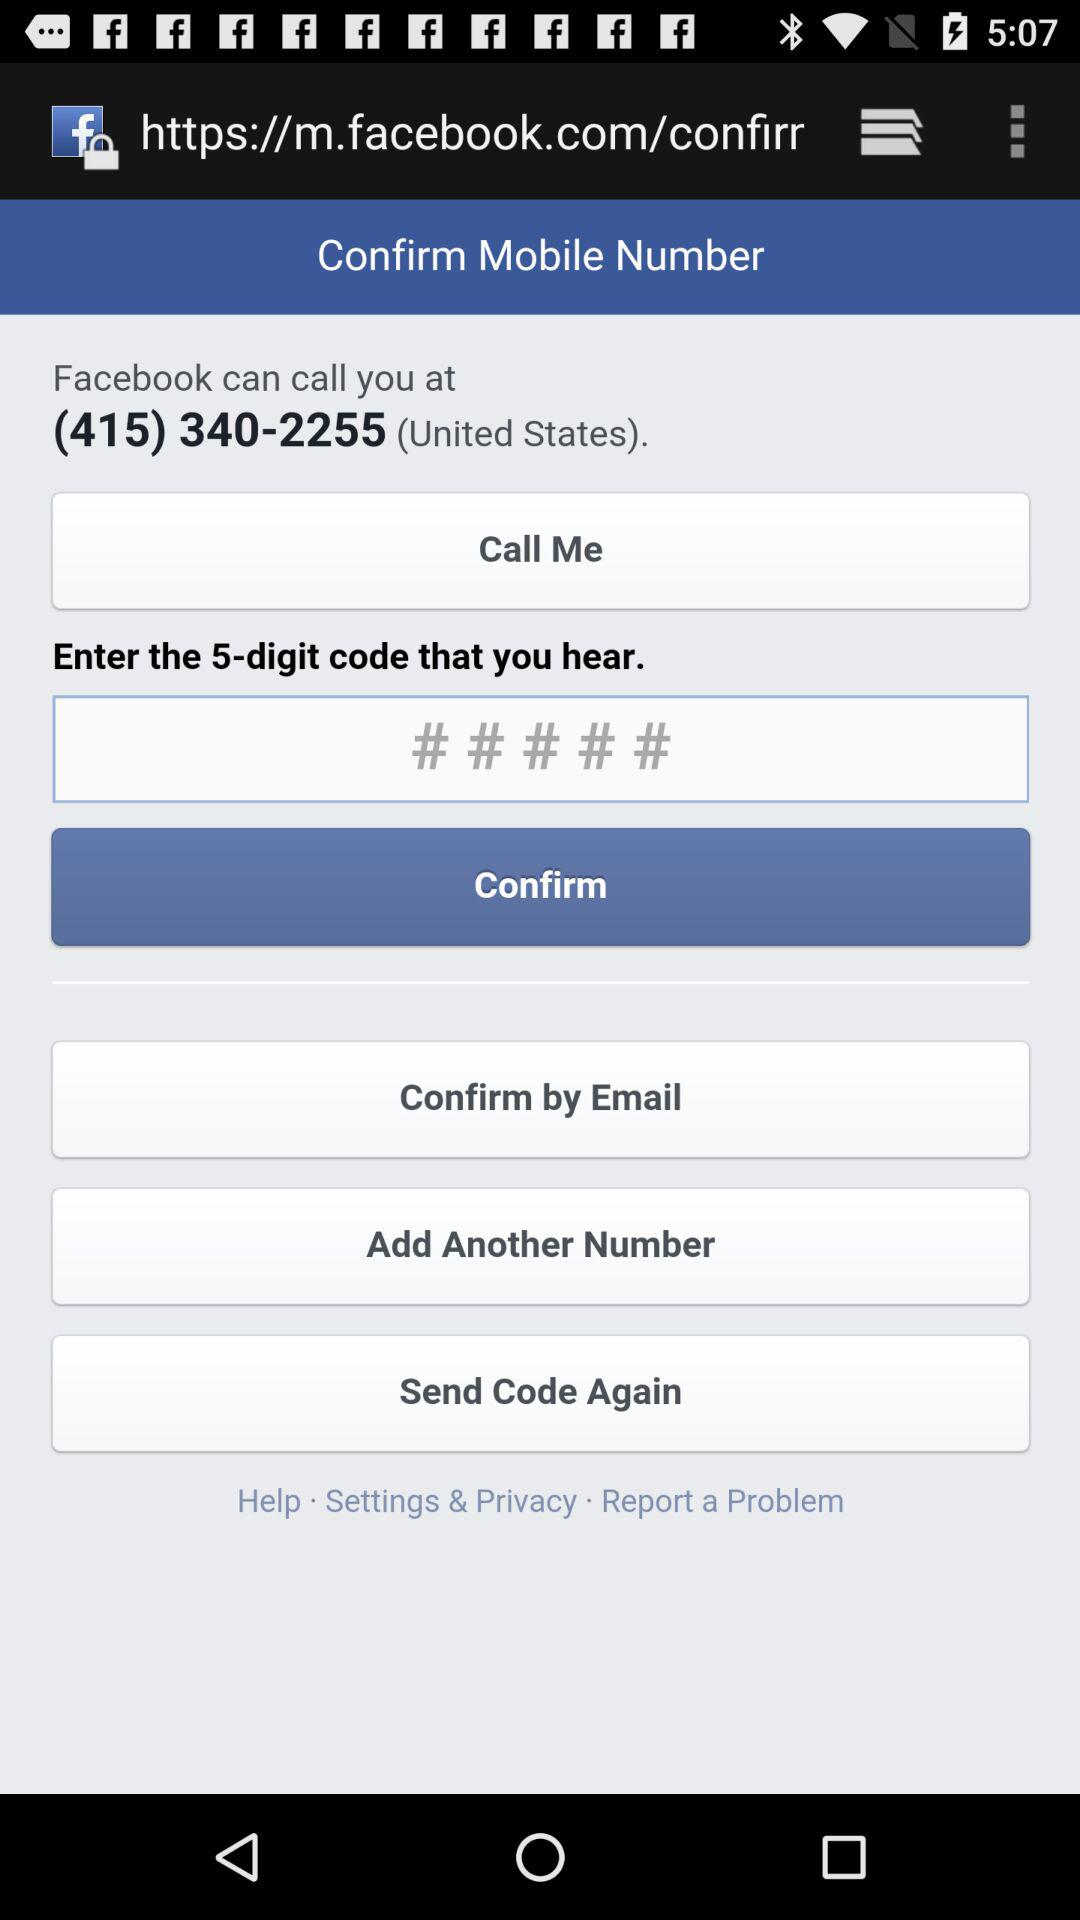How many digits long is the code that I need to enter?
Answer the question using a single word or phrase. 5 